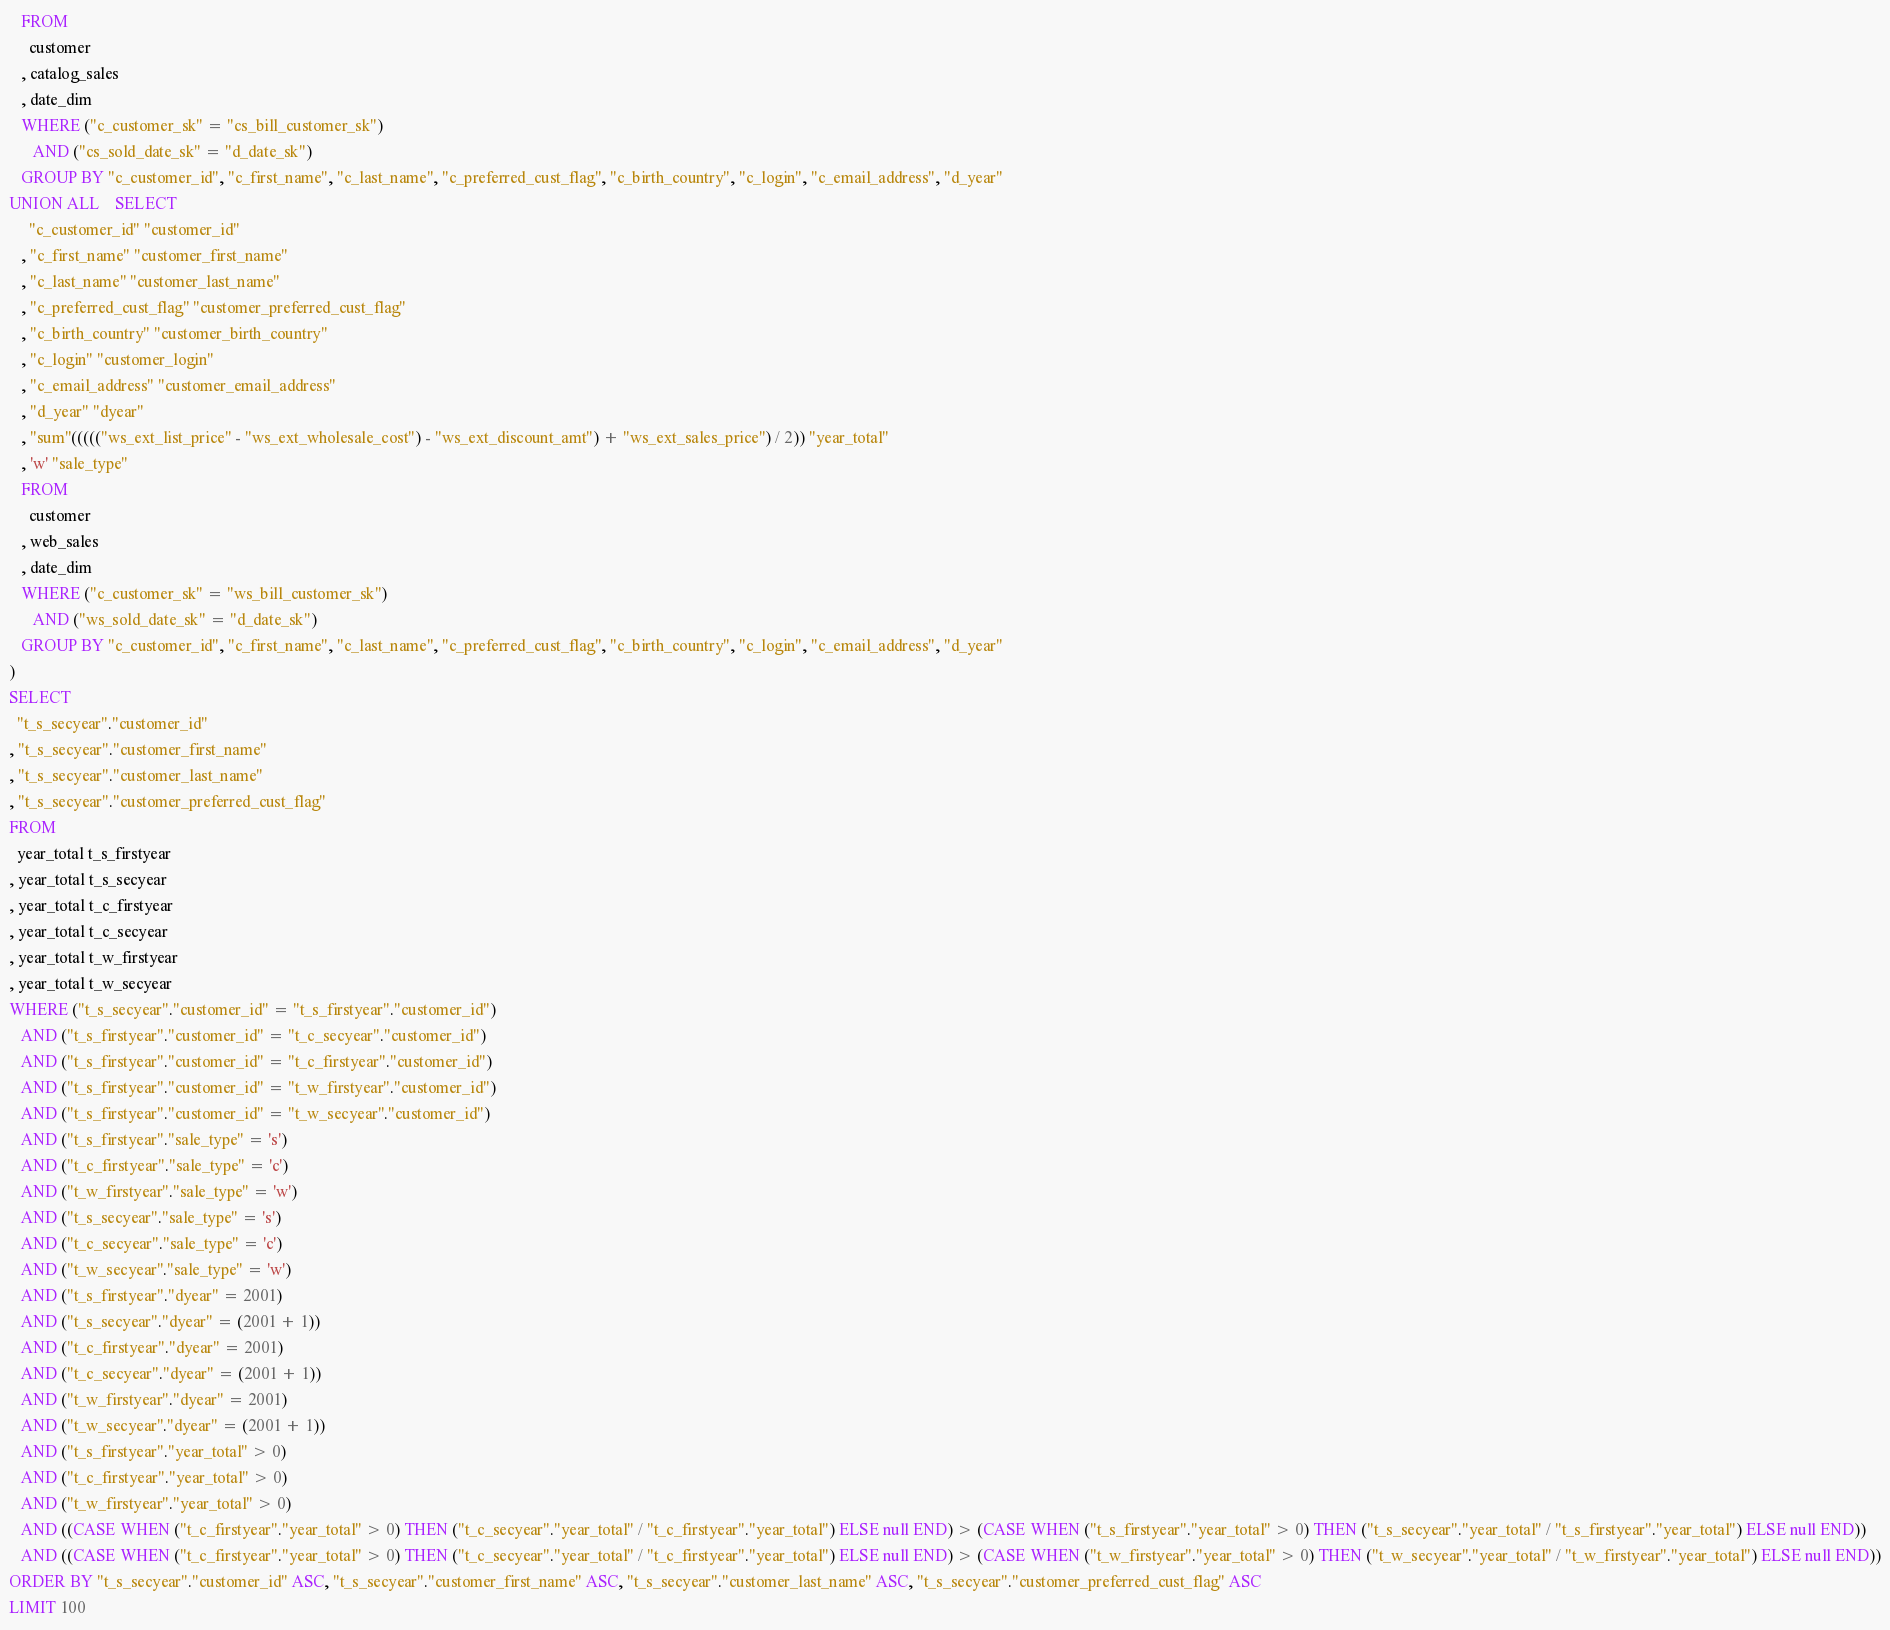Convert code to text. <code><loc_0><loc_0><loc_500><loc_500><_SQL_>   FROM
     customer
   , catalog_sales
   , date_dim
   WHERE ("c_customer_sk" = "cs_bill_customer_sk")
      AND ("cs_sold_date_sk" = "d_date_sk")
   GROUP BY "c_customer_id", "c_first_name", "c_last_name", "c_preferred_cust_flag", "c_birth_country", "c_login", "c_email_address", "d_year"
UNION ALL    SELECT
     "c_customer_id" "customer_id"
   , "c_first_name" "customer_first_name"
   , "c_last_name" "customer_last_name"
   , "c_preferred_cust_flag" "customer_preferred_cust_flag"
   , "c_birth_country" "customer_birth_country"
   , "c_login" "customer_login"
   , "c_email_address" "customer_email_address"
   , "d_year" "dyear"
   , "sum"((((("ws_ext_list_price" - "ws_ext_wholesale_cost") - "ws_ext_discount_amt") + "ws_ext_sales_price") / 2)) "year_total"
   , 'w' "sale_type"
   FROM
     customer
   , web_sales
   , date_dim
   WHERE ("c_customer_sk" = "ws_bill_customer_sk")
      AND ("ws_sold_date_sk" = "d_date_sk")
   GROUP BY "c_customer_id", "c_first_name", "c_last_name", "c_preferred_cust_flag", "c_birth_country", "c_login", "c_email_address", "d_year"
)
SELECT
  "t_s_secyear"."customer_id"
, "t_s_secyear"."customer_first_name"
, "t_s_secyear"."customer_last_name"
, "t_s_secyear"."customer_preferred_cust_flag"
FROM
  year_total t_s_firstyear
, year_total t_s_secyear
, year_total t_c_firstyear
, year_total t_c_secyear
, year_total t_w_firstyear
, year_total t_w_secyear
WHERE ("t_s_secyear"."customer_id" = "t_s_firstyear"."customer_id")
   AND ("t_s_firstyear"."customer_id" = "t_c_secyear"."customer_id")
   AND ("t_s_firstyear"."customer_id" = "t_c_firstyear"."customer_id")
   AND ("t_s_firstyear"."customer_id" = "t_w_firstyear"."customer_id")
   AND ("t_s_firstyear"."customer_id" = "t_w_secyear"."customer_id")
   AND ("t_s_firstyear"."sale_type" = 's')
   AND ("t_c_firstyear"."sale_type" = 'c')
   AND ("t_w_firstyear"."sale_type" = 'w')
   AND ("t_s_secyear"."sale_type" = 's')
   AND ("t_c_secyear"."sale_type" = 'c')
   AND ("t_w_secyear"."sale_type" = 'w')
   AND ("t_s_firstyear"."dyear" = 2001)
   AND ("t_s_secyear"."dyear" = (2001 + 1))
   AND ("t_c_firstyear"."dyear" = 2001)
   AND ("t_c_secyear"."dyear" = (2001 + 1))
   AND ("t_w_firstyear"."dyear" = 2001)
   AND ("t_w_secyear"."dyear" = (2001 + 1))
   AND ("t_s_firstyear"."year_total" > 0)
   AND ("t_c_firstyear"."year_total" > 0)
   AND ("t_w_firstyear"."year_total" > 0)
   AND ((CASE WHEN ("t_c_firstyear"."year_total" > 0) THEN ("t_c_secyear"."year_total" / "t_c_firstyear"."year_total") ELSE null END) > (CASE WHEN ("t_s_firstyear"."year_total" > 0) THEN ("t_s_secyear"."year_total" / "t_s_firstyear"."year_total") ELSE null END))
   AND ((CASE WHEN ("t_c_firstyear"."year_total" > 0) THEN ("t_c_secyear"."year_total" / "t_c_firstyear"."year_total") ELSE null END) > (CASE WHEN ("t_w_firstyear"."year_total" > 0) THEN ("t_w_secyear"."year_total" / "t_w_firstyear"."year_total") ELSE null END))
ORDER BY "t_s_secyear"."customer_id" ASC, "t_s_secyear"."customer_first_name" ASC, "t_s_secyear"."customer_last_name" ASC, "t_s_secyear"."customer_preferred_cust_flag" ASC
LIMIT 100
</code> 